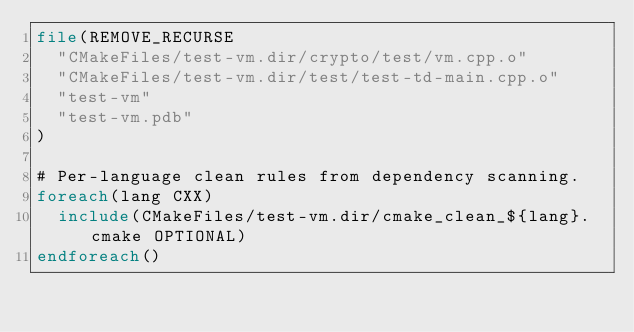<code> <loc_0><loc_0><loc_500><loc_500><_CMake_>file(REMOVE_RECURSE
  "CMakeFiles/test-vm.dir/crypto/test/vm.cpp.o"
  "CMakeFiles/test-vm.dir/test/test-td-main.cpp.o"
  "test-vm"
  "test-vm.pdb"
)

# Per-language clean rules from dependency scanning.
foreach(lang CXX)
  include(CMakeFiles/test-vm.dir/cmake_clean_${lang}.cmake OPTIONAL)
endforeach()
</code> 